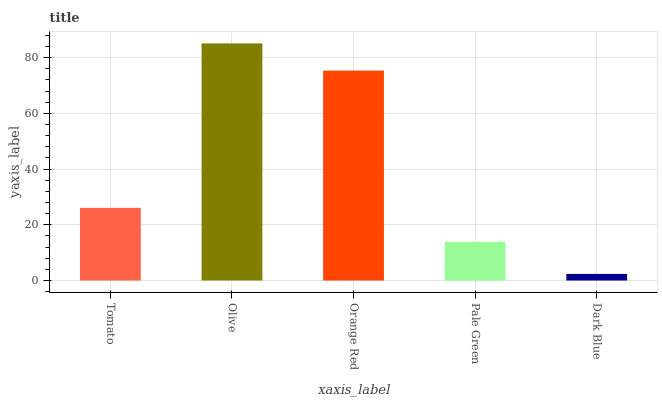Is Orange Red the minimum?
Answer yes or no. No. Is Orange Red the maximum?
Answer yes or no. No. Is Olive greater than Orange Red?
Answer yes or no. Yes. Is Orange Red less than Olive?
Answer yes or no. Yes. Is Orange Red greater than Olive?
Answer yes or no. No. Is Olive less than Orange Red?
Answer yes or no. No. Is Tomato the high median?
Answer yes or no. Yes. Is Tomato the low median?
Answer yes or no. Yes. Is Dark Blue the high median?
Answer yes or no. No. Is Orange Red the low median?
Answer yes or no. No. 